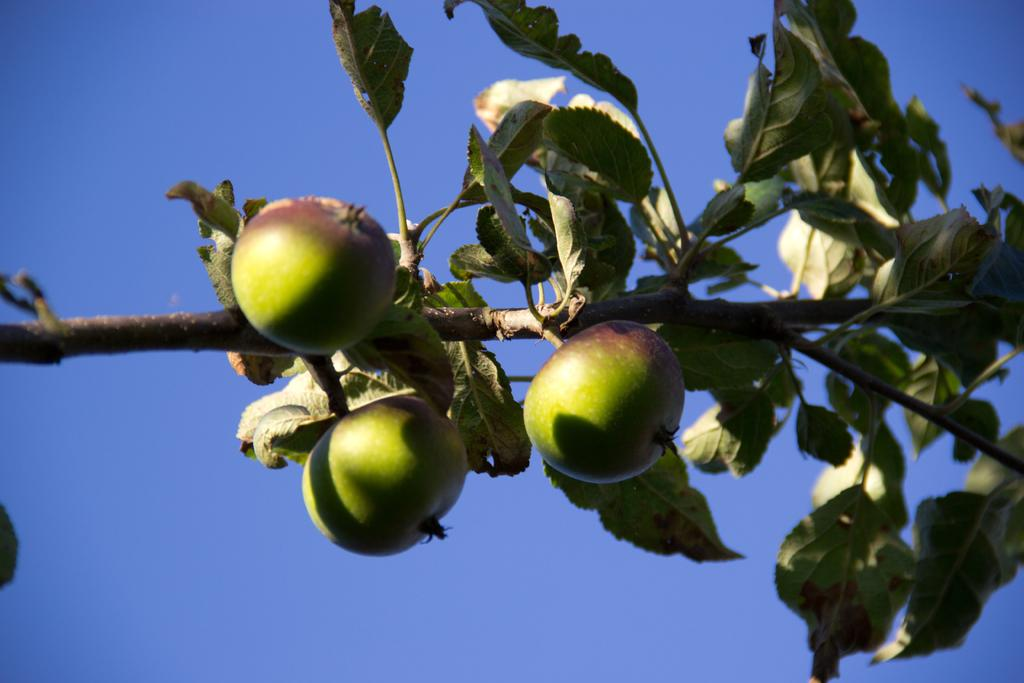What type of living organisms can be seen on the plant in the image? There are fruits on the plant in the image. What colors are the fruits? The fruits are green and brown in color. What can be seen in the background of the image? The background of the image is blue. How many people are in the crowd surrounding the plant in the image? There is no crowd present in the image; it only features a plant with fruits. What type of lipstick is being used by the person holding the plant in the image? There is no person holding the plant in the image, and therefore no lipstick can be observed. 